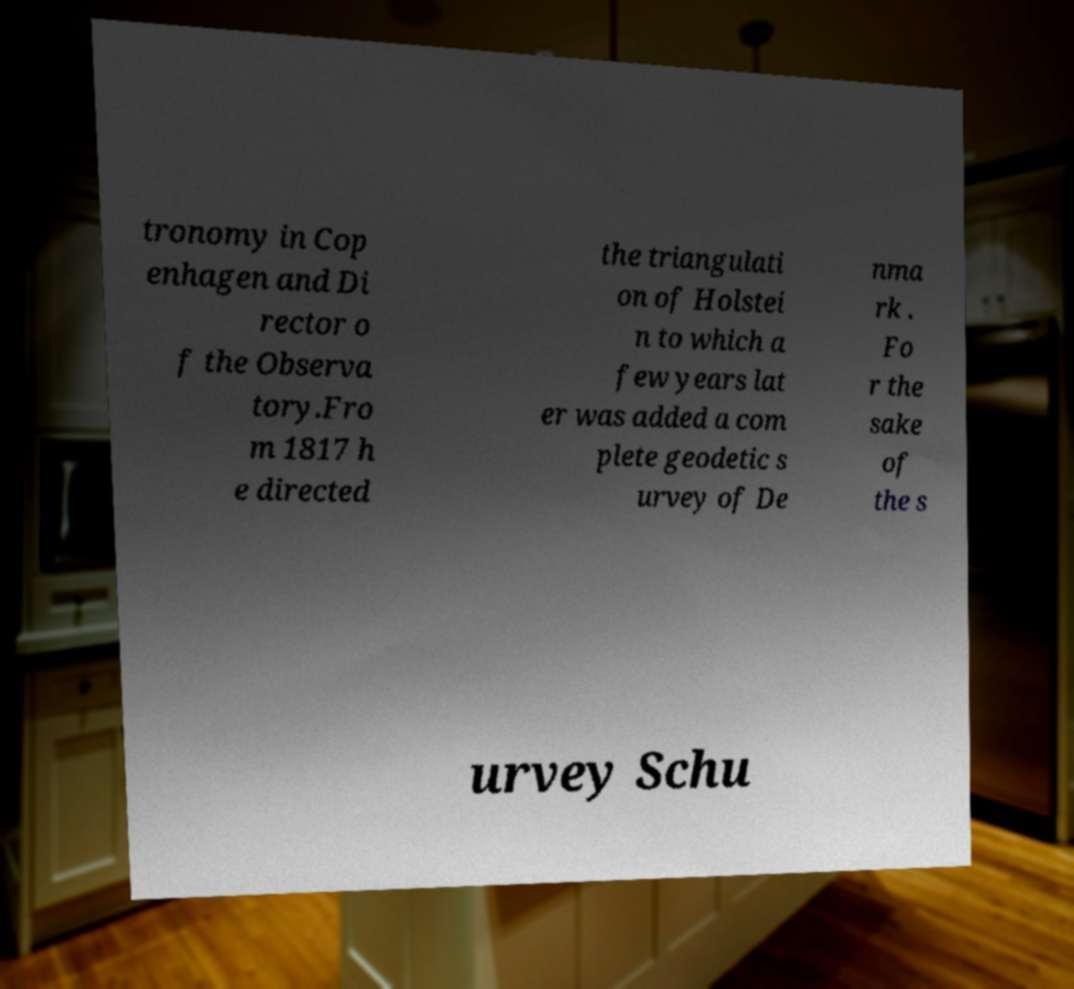Can you read and provide the text displayed in the image?This photo seems to have some interesting text. Can you extract and type it out for me? tronomy in Cop enhagen and Di rector o f the Observa tory.Fro m 1817 h e directed the triangulati on of Holstei n to which a few years lat er was added a com plete geodetic s urvey of De nma rk . Fo r the sake of the s urvey Schu 